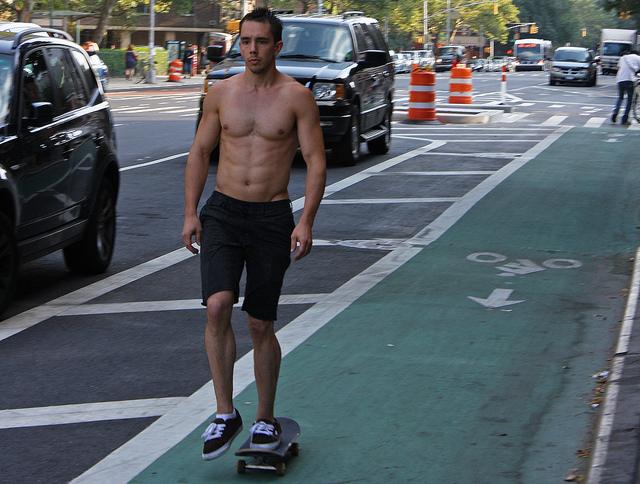Is daytime in this scene?
Short answer required. Yes. What lane is the man skateboarding in?
Give a very brief answer. Bike lane. Is the man skating?
Concise answer only. Yes. 